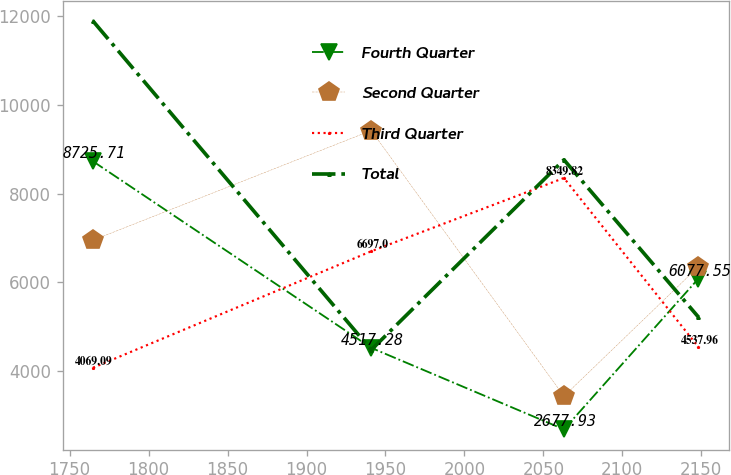Convert chart to OTSL. <chart><loc_0><loc_0><loc_500><loc_500><line_chart><ecel><fcel>Fourth Quarter<fcel>Second Quarter<fcel>Third Quarter<fcel>Total<nl><fcel>1764.78<fcel>8725.71<fcel>6946.69<fcel>4069.09<fcel>11890.7<nl><fcel>1941<fcel>4517.28<fcel>9420.99<fcel>6697<fcel>4472.45<nl><fcel>2063.05<fcel>2677.93<fcel>3426.07<fcel>8349.82<fcel>8760.38<nl><fcel>2148.17<fcel>6077.55<fcel>6347.2<fcel>4537.96<fcel>5214.27<nl></chart> 